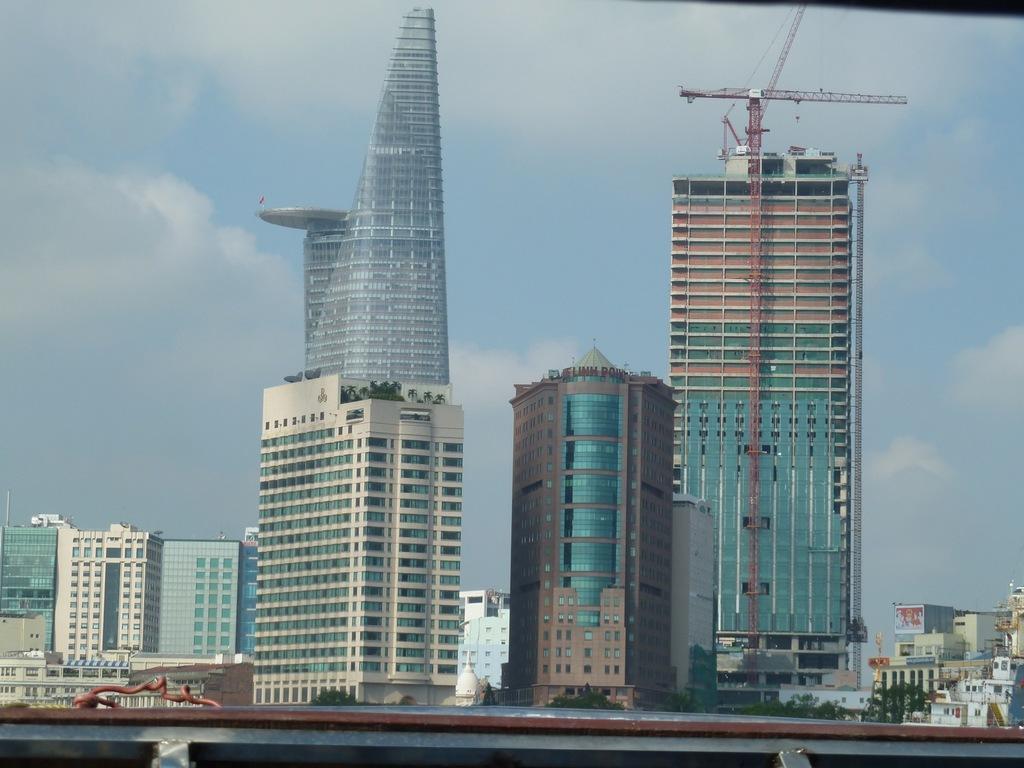Can you describe this image briefly? In this image we can see buildings with windows, crane, plants and in the background we can also see the sky. 